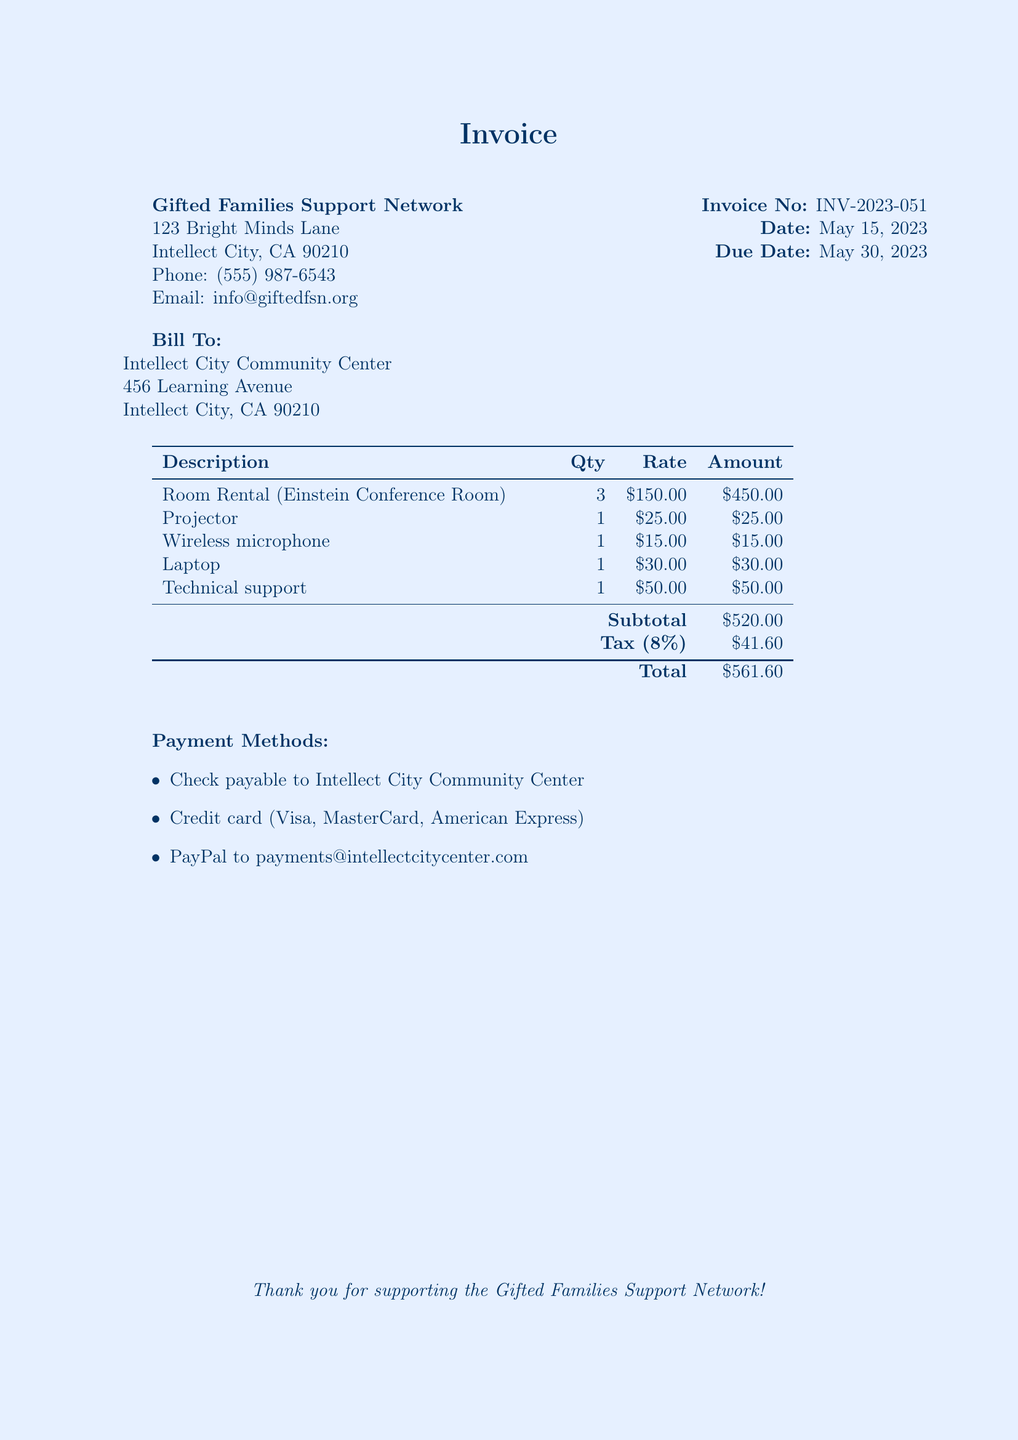what is the invoice number? The invoice number is listed as 'INV-2023-051' in the document.
Answer: INV-2023-051 what is the total amount due? The total amount due is provided in the invoice, which includes subtotal and tax.
Answer: $561.60 how many conference rooms were rented? The document specifies the rental of 'Einstein Conference Room', indicating one conference room was rented.
Answer: 1 what is the tax rate applied in this invoice? The tax rate is mentioned as '8%' in the calculations section.
Answer: 8% what is the quantity of projectors rented? The quantity of projectors rented is specified as '1' in the itemized list.
Answer: 1 what is the subtotal before tax? The subtotal before tax is listed in the document as "Subtotal" which totals up all services and rentals.
Answer: $520.00 when is the payment due? The due date for payment is mentioned in the document as 'May 30, 2023'.
Answer: May 30, 2023 how much does technical support cost? The cost for technical support is clearly stated in the breakdown of fees as a singular amount.
Answer: $50.00 what payment methods are available? The payment methods are listed as check, credit card, and PayPal in the document.
Answer: Check, Credit card, PayPal 